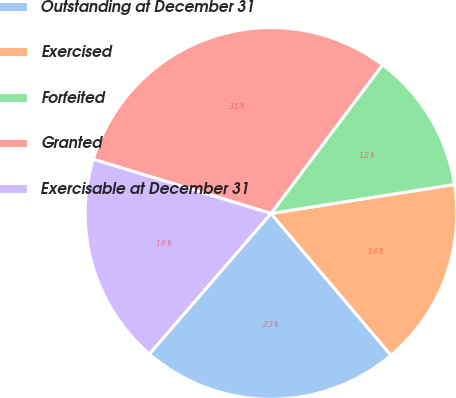Convert chart. <chart><loc_0><loc_0><loc_500><loc_500><pie_chart><fcel>Outstanding at December 31<fcel>Exercised<fcel>Forfeited<fcel>Granted<fcel>Exercisable at December 31<nl><fcel>22.53%<fcel>16.32%<fcel>12.26%<fcel>30.54%<fcel>18.36%<nl></chart> 